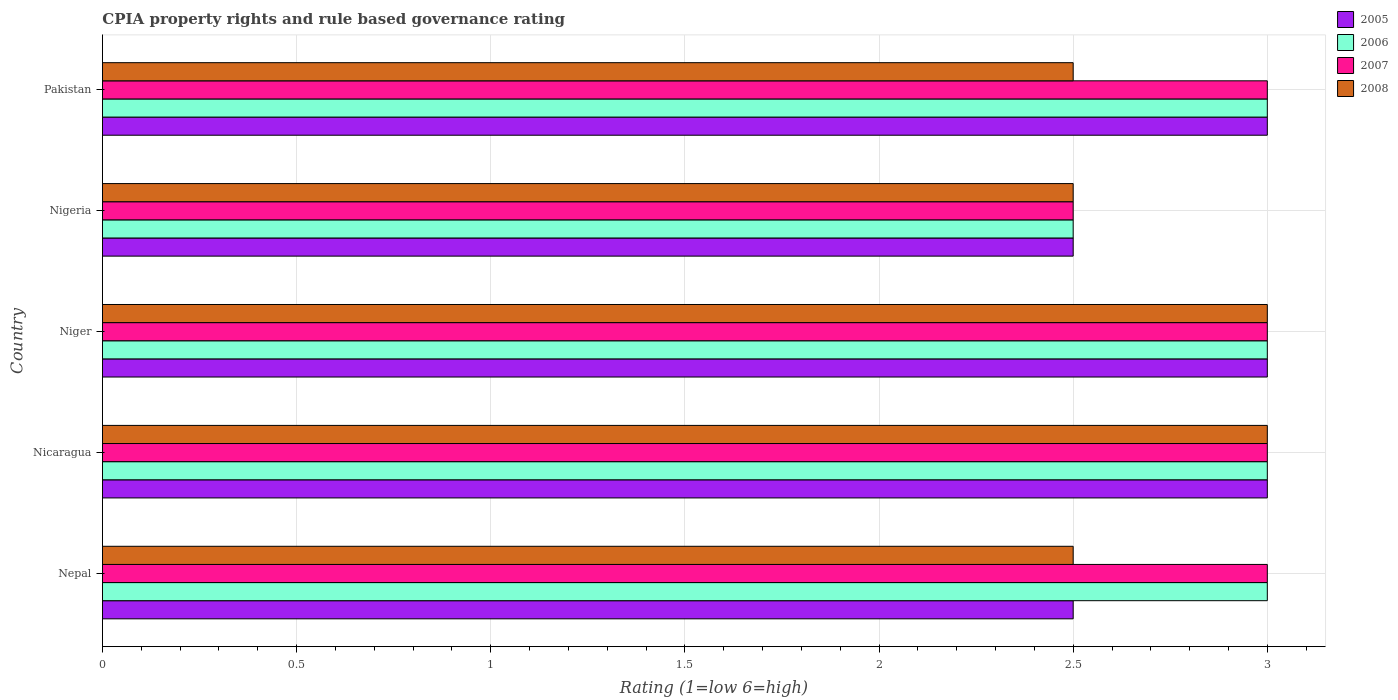How many groups of bars are there?
Your answer should be compact. 5. Are the number of bars per tick equal to the number of legend labels?
Your response must be concise. Yes. Are the number of bars on each tick of the Y-axis equal?
Make the answer very short. Yes. How many bars are there on the 4th tick from the bottom?
Ensure brevity in your answer.  4. What is the label of the 4th group of bars from the top?
Your answer should be very brief. Nicaragua. What is the CPIA rating in 2007 in Niger?
Keep it short and to the point. 3. In which country was the CPIA rating in 2005 maximum?
Give a very brief answer. Nicaragua. In which country was the CPIA rating in 2008 minimum?
Make the answer very short. Nepal. What is the total CPIA rating in 2008 in the graph?
Offer a terse response. 13.5. What is the difference between the CPIA rating in 2006 in Niger and that in Pakistan?
Provide a short and direct response. 0. What is the difference between the CPIA rating in 2008 in Nigeria and the CPIA rating in 2006 in Nicaragua?
Keep it short and to the point. -0.5. In how many countries, is the CPIA rating in 2006 greater than the average CPIA rating in 2006 taken over all countries?
Ensure brevity in your answer.  4. Is it the case that in every country, the sum of the CPIA rating in 2007 and CPIA rating in 2008 is greater than the sum of CPIA rating in 2005 and CPIA rating in 2006?
Provide a succinct answer. No. Is it the case that in every country, the sum of the CPIA rating in 2005 and CPIA rating in 2007 is greater than the CPIA rating in 2006?
Keep it short and to the point. Yes. How many bars are there?
Make the answer very short. 20. How many countries are there in the graph?
Your answer should be very brief. 5. What is the difference between two consecutive major ticks on the X-axis?
Your answer should be very brief. 0.5. Are the values on the major ticks of X-axis written in scientific E-notation?
Offer a very short reply. No. Does the graph contain any zero values?
Your answer should be very brief. No. Does the graph contain grids?
Keep it short and to the point. Yes. Where does the legend appear in the graph?
Your answer should be compact. Top right. How many legend labels are there?
Your response must be concise. 4. What is the title of the graph?
Give a very brief answer. CPIA property rights and rule based governance rating. Does "2002" appear as one of the legend labels in the graph?
Offer a terse response. No. What is the label or title of the Y-axis?
Provide a short and direct response. Country. What is the Rating (1=low 6=high) of 2006 in Nepal?
Your answer should be compact. 3. What is the Rating (1=low 6=high) in 2007 in Nepal?
Make the answer very short. 3. What is the Rating (1=low 6=high) of 2007 in Nicaragua?
Your answer should be compact. 3. What is the Rating (1=low 6=high) of 2008 in Nicaragua?
Provide a succinct answer. 3. What is the Rating (1=low 6=high) of 2005 in Niger?
Provide a succinct answer. 3. What is the Rating (1=low 6=high) of 2007 in Niger?
Keep it short and to the point. 3. What is the Rating (1=low 6=high) in 2008 in Niger?
Provide a short and direct response. 3. What is the Rating (1=low 6=high) of 2005 in Nigeria?
Provide a succinct answer. 2.5. What is the Rating (1=low 6=high) in 2006 in Nigeria?
Offer a very short reply. 2.5. What is the Rating (1=low 6=high) in 2008 in Nigeria?
Offer a terse response. 2.5. What is the Rating (1=low 6=high) of 2005 in Pakistan?
Give a very brief answer. 3. What is the Rating (1=low 6=high) in 2006 in Pakistan?
Offer a very short reply. 3. Across all countries, what is the maximum Rating (1=low 6=high) of 2006?
Keep it short and to the point. 3. Across all countries, what is the maximum Rating (1=low 6=high) of 2008?
Your answer should be compact. 3. Across all countries, what is the minimum Rating (1=low 6=high) in 2005?
Make the answer very short. 2.5. What is the total Rating (1=low 6=high) in 2005 in the graph?
Provide a short and direct response. 14. What is the total Rating (1=low 6=high) in 2006 in the graph?
Provide a short and direct response. 14.5. What is the total Rating (1=low 6=high) in 2007 in the graph?
Ensure brevity in your answer.  14.5. What is the difference between the Rating (1=low 6=high) of 2008 in Nepal and that in Nicaragua?
Offer a very short reply. -0.5. What is the difference between the Rating (1=low 6=high) of 2006 in Nepal and that in Niger?
Your answer should be compact. 0. What is the difference between the Rating (1=low 6=high) in 2007 in Nepal and that in Niger?
Ensure brevity in your answer.  0. What is the difference between the Rating (1=low 6=high) in 2008 in Nepal and that in Niger?
Give a very brief answer. -0.5. What is the difference between the Rating (1=low 6=high) of 2007 in Nepal and that in Pakistan?
Your answer should be compact. 0. What is the difference between the Rating (1=low 6=high) in 2008 in Nepal and that in Pakistan?
Provide a succinct answer. 0. What is the difference between the Rating (1=low 6=high) in 2006 in Nicaragua and that in Niger?
Give a very brief answer. 0. What is the difference between the Rating (1=low 6=high) of 2008 in Nicaragua and that in Niger?
Provide a short and direct response. 0. What is the difference between the Rating (1=low 6=high) in 2007 in Nicaragua and that in Nigeria?
Make the answer very short. 0.5. What is the difference between the Rating (1=low 6=high) of 2007 in Nicaragua and that in Pakistan?
Provide a short and direct response. 0. What is the difference between the Rating (1=low 6=high) in 2008 in Nicaragua and that in Pakistan?
Give a very brief answer. 0.5. What is the difference between the Rating (1=low 6=high) of 2005 in Niger and that in Nigeria?
Provide a succinct answer. 0.5. What is the difference between the Rating (1=low 6=high) of 2005 in Niger and that in Pakistan?
Provide a succinct answer. 0. What is the difference between the Rating (1=low 6=high) of 2007 in Niger and that in Pakistan?
Provide a succinct answer. 0. What is the difference between the Rating (1=low 6=high) in 2008 in Niger and that in Pakistan?
Offer a terse response. 0.5. What is the difference between the Rating (1=low 6=high) in 2005 in Nigeria and that in Pakistan?
Make the answer very short. -0.5. What is the difference between the Rating (1=low 6=high) in 2006 in Nigeria and that in Pakistan?
Make the answer very short. -0.5. What is the difference between the Rating (1=low 6=high) in 2007 in Nigeria and that in Pakistan?
Give a very brief answer. -0.5. What is the difference between the Rating (1=low 6=high) in 2005 in Nepal and the Rating (1=low 6=high) in 2007 in Nicaragua?
Your response must be concise. -0.5. What is the difference between the Rating (1=low 6=high) of 2005 in Nepal and the Rating (1=low 6=high) of 2008 in Nicaragua?
Offer a very short reply. -0.5. What is the difference between the Rating (1=low 6=high) in 2005 in Nepal and the Rating (1=low 6=high) in 2006 in Niger?
Make the answer very short. -0.5. What is the difference between the Rating (1=low 6=high) of 2005 in Nepal and the Rating (1=low 6=high) of 2008 in Niger?
Give a very brief answer. -0.5. What is the difference between the Rating (1=low 6=high) of 2007 in Nepal and the Rating (1=low 6=high) of 2008 in Niger?
Offer a very short reply. 0. What is the difference between the Rating (1=low 6=high) of 2005 in Nepal and the Rating (1=low 6=high) of 2008 in Nigeria?
Your answer should be compact. 0. What is the difference between the Rating (1=low 6=high) of 2006 in Nepal and the Rating (1=low 6=high) of 2007 in Nigeria?
Your answer should be very brief. 0.5. What is the difference between the Rating (1=low 6=high) of 2006 in Nepal and the Rating (1=low 6=high) of 2008 in Nigeria?
Offer a terse response. 0.5. What is the difference between the Rating (1=low 6=high) in 2005 in Nepal and the Rating (1=low 6=high) in 2006 in Pakistan?
Your response must be concise. -0.5. What is the difference between the Rating (1=low 6=high) of 2005 in Nepal and the Rating (1=low 6=high) of 2007 in Pakistan?
Offer a terse response. -0.5. What is the difference between the Rating (1=low 6=high) of 2005 in Nepal and the Rating (1=low 6=high) of 2008 in Pakistan?
Provide a succinct answer. 0. What is the difference between the Rating (1=low 6=high) in 2006 in Nepal and the Rating (1=low 6=high) in 2007 in Pakistan?
Your answer should be very brief. 0. What is the difference between the Rating (1=low 6=high) in 2006 in Nepal and the Rating (1=low 6=high) in 2008 in Pakistan?
Your answer should be compact. 0.5. What is the difference between the Rating (1=low 6=high) in 2007 in Nepal and the Rating (1=low 6=high) in 2008 in Pakistan?
Ensure brevity in your answer.  0.5. What is the difference between the Rating (1=low 6=high) in 2005 in Nicaragua and the Rating (1=low 6=high) in 2006 in Niger?
Give a very brief answer. 0. What is the difference between the Rating (1=low 6=high) of 2005 in Nicaragua and the Rating (1=low 6=high) of 2008 in Niger?
Offer a very short reply. 0. What is the difference between the Rating (1=low 6=high) in 2006 in Nicaragua and the Rating (1=low 6=high) in 2007 in Niger?
Give a very brief answer. 0. What is the difference between the Rating (1=low 6=high) in 2006 in Nicaragua and the Rating (1=low 6=high) in 2008 in Niger?
Ensure brevity in your answer.  0. What is the difference between the Rating (1=low 6=high) of 2005 in Nicaragua and the Rating (1=low 6=high) of 2007 in Nigeria?
Your response must be concise. 0.5. What is the difference between the Rating (1=low 6=high) in 2005 in Nicaragua and the Rating (1=low 6=high) in 2008 in Nigeria?
Provide a short and direct response. 0.5. What is the difference between the Rating (1=low 6=high) of 2006 in Nicaragua and the Rating (1=low 6=high) of 2008 in Pakistan?
Your response must be concise. 0.5. What is the difference between the Rating (1=low 6=high) of 2005 in Niger and the Rating (1=low 6=high) of 2006 in Nigeria?
Keep it short and to the point. 0.5. What is the difference between the Rating (1=low 6=high) in 2005 in Niger and the Rating (1=low 6=high) in 2007 in Nigeria?
Provide a succinct answer. 0.5. What is the difference between the Rating (1=low 6=high) in 2005 in Niger and the Rating (1=low 6=high) in 2008 in Nigeria?
Your response must be concise. 0.5. What is the difference between the Rating (1=low 6=high) of 2006 in Niger and the Rating (1=low 6=high) of 2007 in Nigeria?
Ensure brevity in your answer.  0.5. What is the difference between the Rating (1=low 6=high) of 2006 in Niger and the Rating (1=low 6=high) of 2008 in Nigeria?
Keep it short and to the point. 0.5. What is the difference between the Rating (1=low 6=high) in 2006 in Niger and the Rating (1=low 6=high) in 2007 in Pakistan?
Your answer should be compact. 0. What is the difference between the Rating (1=low 6=high) of 2006 in Niger and the Rating (1=low 6=high) of 2008 in Pakistan?
Provide a short and direct response. 0.5. What is the difference between the Rating (1=low 6=high) in 2005 in Nigeria and the Rating (1=low 6=high) in 2007 in Pakistan?
Give a very brief answer. -0.5. What is the difference between the Rating (1=low 6=high) in 2005 in Nigeria and the Rating (1=low 6=high) in 2008 in Pakistan?
Your answer should be very brief. 0. What is the difference between the Rating (1=low 6=high) of 2006 in Nigeria and the Rating (1=low 6=high) of 2008 in Pakistan?
Make the answer very short. 0. What is the average Rating (1=low 6=high) of 2005 per country?
Give a very brief answer. 2.8. What is the average Rating (1=low 6=high) in 2007 per country?
Provide a short and direct response. 2.9. What is the average Rating (1=low 6=high) of 2008 per country?
Offer a very short reply. 2.7. What is the difference between the Rating (1=low 6=high) of 2005 and Rating (1=low 6=high) of 2008 in Nepal?
Give a very brief answer. 0. What is the difference between the Rating (1=low 6=high) of 2006 and Rating (1=low 6=high) of 2007 in Nepal?
Keep it short and to the point. 0. What is the difference between the Rating (1=low 6=high) in 2006 and Rating (1=low 6=high) in 2008 in Nepal?
Give a very brief answer. 0.5. What is the difference between the Rating (1=low 6=high) of 2005 and Rating (1=low 6=high) of 2006 in Nicaragua?
Give a very brief answer. 0. What is the difference between the Rating (1=low 6=high) in 2005 and Rating (1=low 6=high) in 2008 in Niger?
Give a very brief answer. 0. What is the difference between the Rating (1=low 6=high) in 2006 and Rating (1=low 6=high) in 2007 in Niger?
Your response must be concise. 0. What is the difference between the Rating (1=low 6=high) of 2006 and Rating (1=low 6=high) of 2008 in Niger?
Your answer should be compact. 0. What is the difference between the Rating (1=low 6=high) of 2005 and Rating (1=low 6=high) of 2008 in Nigeria?
Keep it short and to the point. 0. What is the difference between the Rating (1=low 6=high) of 2006 and Rating (1=low 6=high) of 2007 in Nigeria?
Give a very brief answer. 0. What is the difference between the Rating (1=low 6=high) of 2005 and Rating (1=low 6=high) of 2006 in Pakistan?
Your answer should be very brief. 0. What is the difference between the Rating (1=low 6=high) in 2007 and Rating (1=low 6=high) in 2008 in Pakistan?
Provide a succinct answer. 0.5. What is the ratio of the Rating (1=low 6=high) in 2006 in Nepal to that in Nicaragua?
Keep it short and to the point. 1. What is the ratio of the Rating (1=low 6=high) of 2008 in Nepal to that in Nicaragua?
Make the answer very short. 0.83. What is the ratio of the Rating (1=low 6=high) of 2007 in Nepal to that in Niger?
Make the answer very short. 1. What is the ratio of the Rating (1=low 6=high) in 2007 in Nepal to that in Nigeria?
Make the answer very short. 1.2. What is the ratio of the Rating (1=low 6=high) in 2005 in Nepal to that in Pakistan?
Your answer should be compact. 0.83. What is the ratio of the Rating (1=low 6=high) in 2006 in Nepal to that in Pakistan?
Your answer should be very brief. 1. What is the ratio of the Rating (1=low 6=high) of 2007 in Nepal to that in Pakistan?
Your answer should be very brief. 1. What is the ratio of the Rating (1=low 6=high) in 2006 in Nicaragua to that in Niger?
Keep it short and to the point. 1. What is the ratio of the Rating (1=low 6=high) of 2008 in Nicaragua to that in Niger?
Ensure brevity in your answer.  1. What is the ratio of the Rating (1=low 6=high) in 2005 in Nicaragua to that in Nigeria?
Provide a succinct answer. 1.2. What is the ratio of the Rating (1=low 6=high) of 2006 in Nicaragua to that in Nigeria?
Keep it short and to the point. 1.2. What is the ratio of the Rating (1=low 6=high) in 2005 in Nicaragua to that in Pakistan?
Offer a terse response. 1. What is the ratio of the Rating (1=low 6=high) of 2006 in Nicaragua to that in Pakistan?
Provide a short and direct response. 1. What is the ratio of the Rating (1=low 6=high) in 2007 in Nicaragua to that in Pakistan?
Your answer should be very brief. 1. What is the ratio of the Rating (1=low 6=high) in 2008 in Nicaragua to that in Pakistan?
Your answer should be very brief. 1.2. What is the ratio of the Rating (1=low 6=high) of 2006 in Niger to that in Nigeria?
Your answer should be compact. 1.2. What is the ratio of the Rating (1=low 6=high) of 2008 in Niger to that in Nigeria?
Your answer should be very brief. 1.2. What is the ratio of the Rating (1=low 6=high) of 2006 in Niger to that in Pakistan?
Provide a short and direct response. 1. What is the ratio of the Rating (1=low 6=high) in 2005 in Nigeria to that in Pakistan?
Provide a succinct answer. 0.83. What is the ratio of the Rating (1=low 6=high) of 2006 in Nigeria to that in Pakistan?
Provide a succinct answer. 0.83. What is the ratio of the Rating (1=low 6=high) in 2007 in Nigeria to that in Pakistan?
Keep it short and to the point. 0.83. What is the ratio of the Rating (1=low 6=high) of 2008 in Nigeria to that in Pakistan?
Offer a terse response. 1. What is the difference between the highest and the second highest Rating (1=low 6=high) of 2005?
Offer a terse response. 0. What is the difference between the highest and the lowest Rating (1=low 6=high) of 2006?
Your response must be concise. 0.5. 